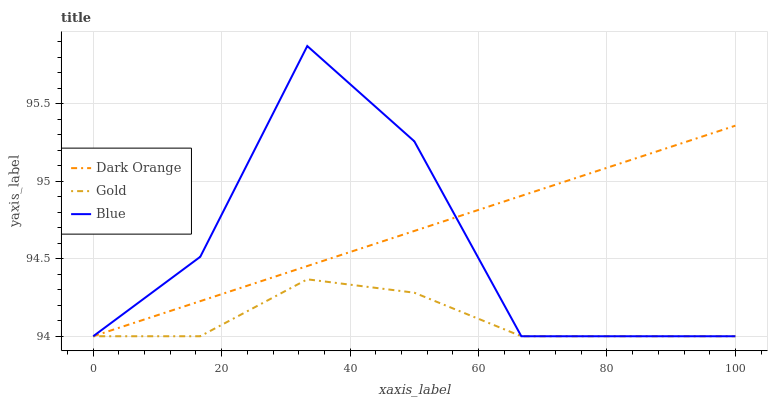Does Dark Orange have the minimum area under the curve?
Answer yes or no. No. Does Gold have the maximum area under the curve?
Answer yes or no. No. Is Gold the smoothest?
Answer yes or no. No. Is Gold the roughest?
Answer yes or no. No. Does Dark Orange have the highest value?
Answer yes or no. No. 